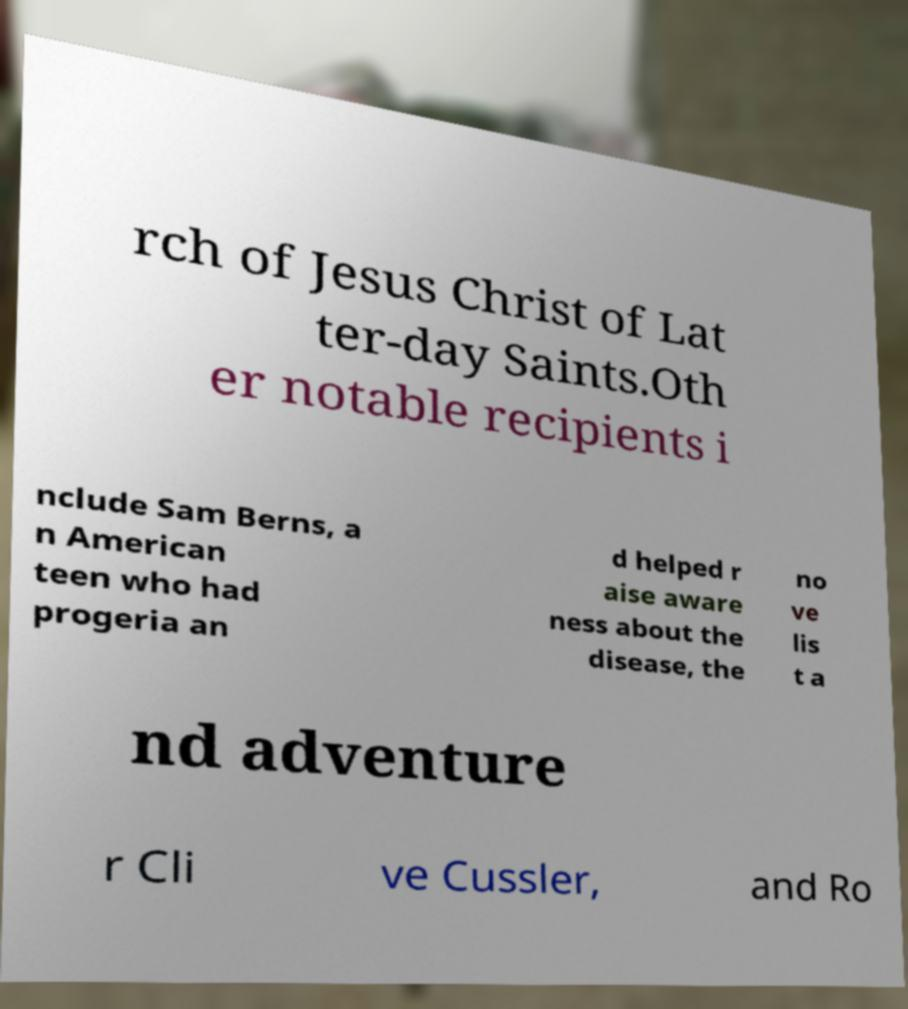There's text embedded in this image that I need extracted. Can you transcribe it verbatim? rch of Jesus Christ of Lat ter-day Saints.Oth er notable recipients i nclude Sam Berns, a n American teen who had progeria an d helped r aise aware ness about the disease, the no ve lis t a nd adventure r Cli ve Cussler, and Ro 